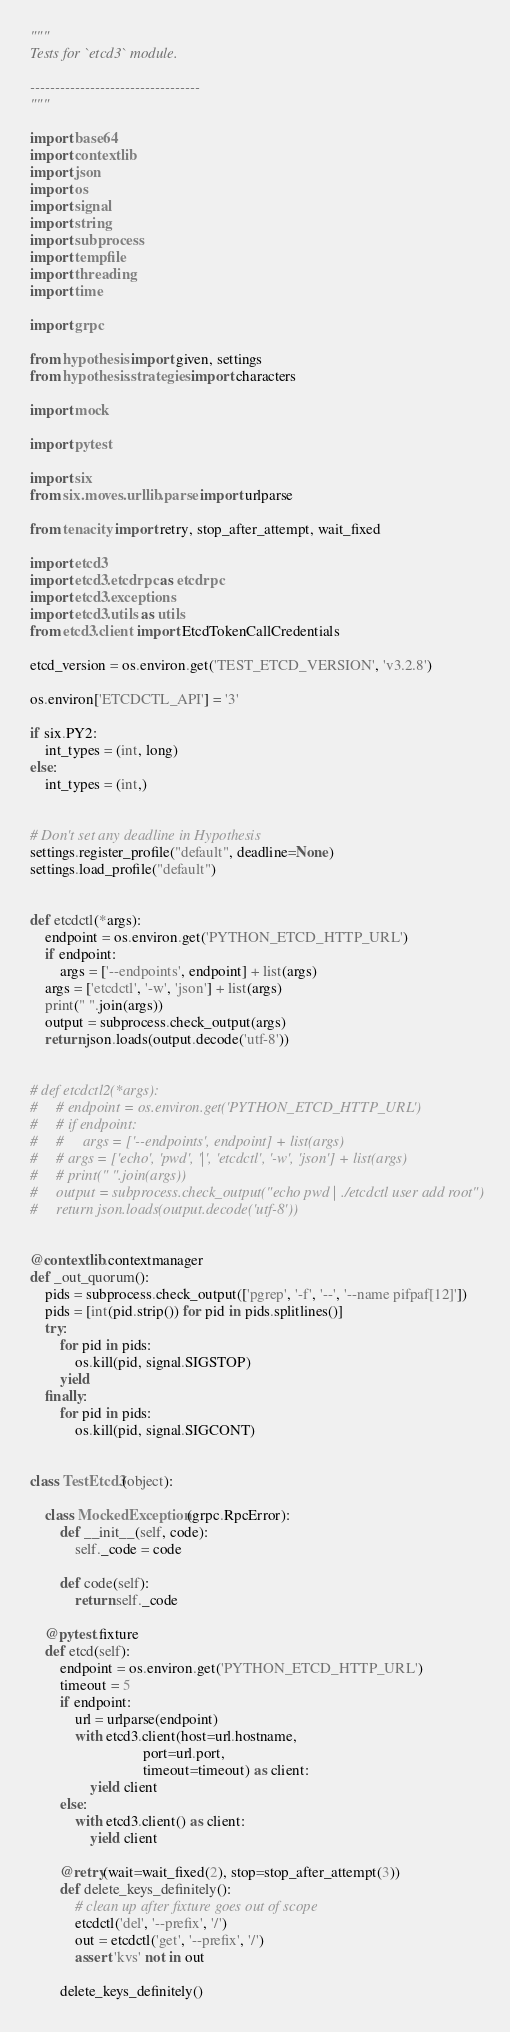<code> <loc_0><loc_0><loc_500><loc_500><_Python_>"""
Tests for `etcd3` module.

----------------------------------
"""

import base64
import contextlib
import json
import os
import signal
import string
import subprocess
import tempfile
import threading
import time

import grpc

from hypothesis import given, settings
from hypothesis.strategies import characters

import mock

import pytest

import six
from six.moves.urllib.parse import urlparse

from tenacity import retry, stop_after_attempt, wait_fixed

import etcd3
import etcd3.etcdrpc as etcdrpc
import etcd3.exceptions
import etcd3.utils as utils
from etcd3.client import EtcdTokenCallCredentials

etcd_version = os.environ.get('TEST_ETCD_VERSION', 'v3.2.8')

os.environ['ETCDCTL_API'] = '3'

if six.PY2:
    int_types = (int, long)
else:
    int_types = (int,)


# Don't set any deadline in Hypothesis
settings.register_profile("default", deadline=None)
settings.load_profile("default")


def etcdctl(*args):
    endpoint = os.environ.get('PYTHON_ETCD_HTTP_URL')
    if endpoint:
        args = ['--endpoints', endpoint] + list(args)
    args = ['etcdctl', '-w', 'json'] + list(args)
    print(" ".join(args))
    output = subprocess.check_output(args)
    return json.loads(output.decode('utf-8'))


# def etcdctl2(*args):
#     # endpoint = os.environ.get('PYTHON_ETCD_HTTP_URL')
#     # if endpoint:
#     #     args = ['--endpoints', endpoint] + list(args)
#     # args = ['echo', 'pwd', '|', 'etcdctl', '-w', 'json'] + list(args)
#     # print(" ".join(args))
#     output = subprocess.check_output("echo pwd | ./etcdctl user add root")
#     return json.loads(output.decode('utf-8'))


@contextlib.contextmanager
def _out_quorum():
    pids = subprocess.check_output(['pgrep', '-f', '--', '--name pifpaf[12]'])
    pids = [int(pid.strip()) for pid in pids.splitlines()]
    try:
        for pid in pids:
            os.kill(pid, signal.SIGSTOP)
        yield
    finally:
        for pid in pids:
            os.kill(pid, signal.SIGCONT)


class TestEtcd3(object):

    class MockedException(grpc.RpcError):
        def __init__(self, code):
            self._code = code

        def code(self):
            return self._code

    @pytest.fixture
    def etcd(self):
        endpoint = os.environ.get('PYTHON_ETCD_HTTP_URL')
        timeout = 5
        if endpoint:
            url = urlparse(endpoint)
            with etcd3.client(host=url.hostname,
                              port=url.port,
                              timeout=timeout) as client:
                yield client
        else:
            with etcd3.client() as client:
                yield client

        @retry(wait=wait_fixed(2), stop=stop_after_attempt(3))
        def delete_keys_definitely():
            # clean up after fixture goes out of scope
            etcdctl('del', '--prefix', '/')
            out = etcdctl('get', '--prefix', '/')
            assert 'kvs' not in out

        delete_keys_definitely()
</code> 